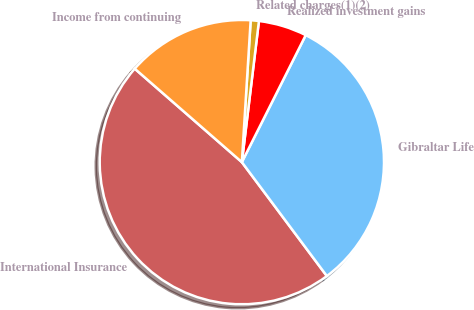Convert chart to OTSL. <chart><loc_0><loc_0><loc_500><loc_500><pie_chart><fcel>International Insurance<fcel>Gibraltar Life<fcel>Realized investment gains<fcel>Related charges(1)(2)<fcel>Income from continuing<nl><fcel>46.62%<fcel>32.38%<fcel>5.5%<fcel>0.93%<fcel>14.57%<nl></chart> 